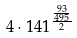<formula> <loc_0><loc_0><loc_500><loc_500>4 \cdot 1 4 1 ^ { \frac { \frac { 9 3 } { 4 9 5 } } { 2 } }</formula> 